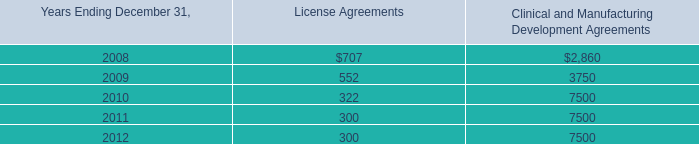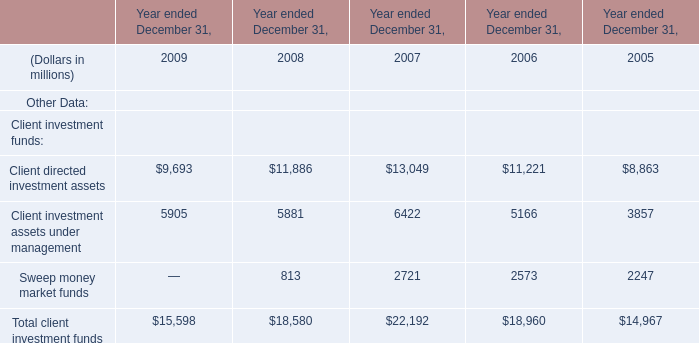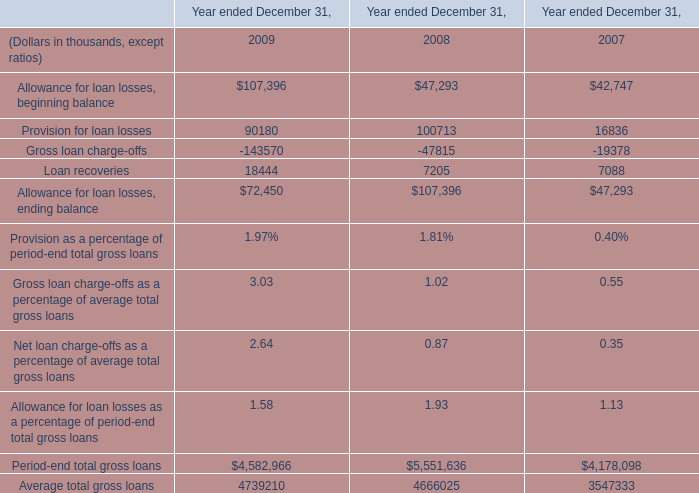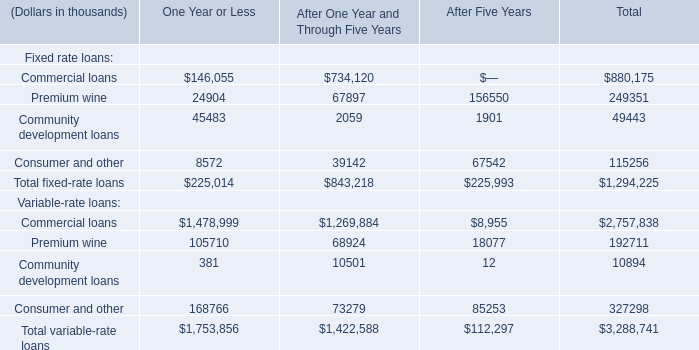What's the average of Sweep money market funds of Year ended December 31, 2006, and Provision for loan losses of Year ended December 31, 2008 ? 
Computations: ((2573.0 + 100713.0) / 2)
Answer: 51643.0. 